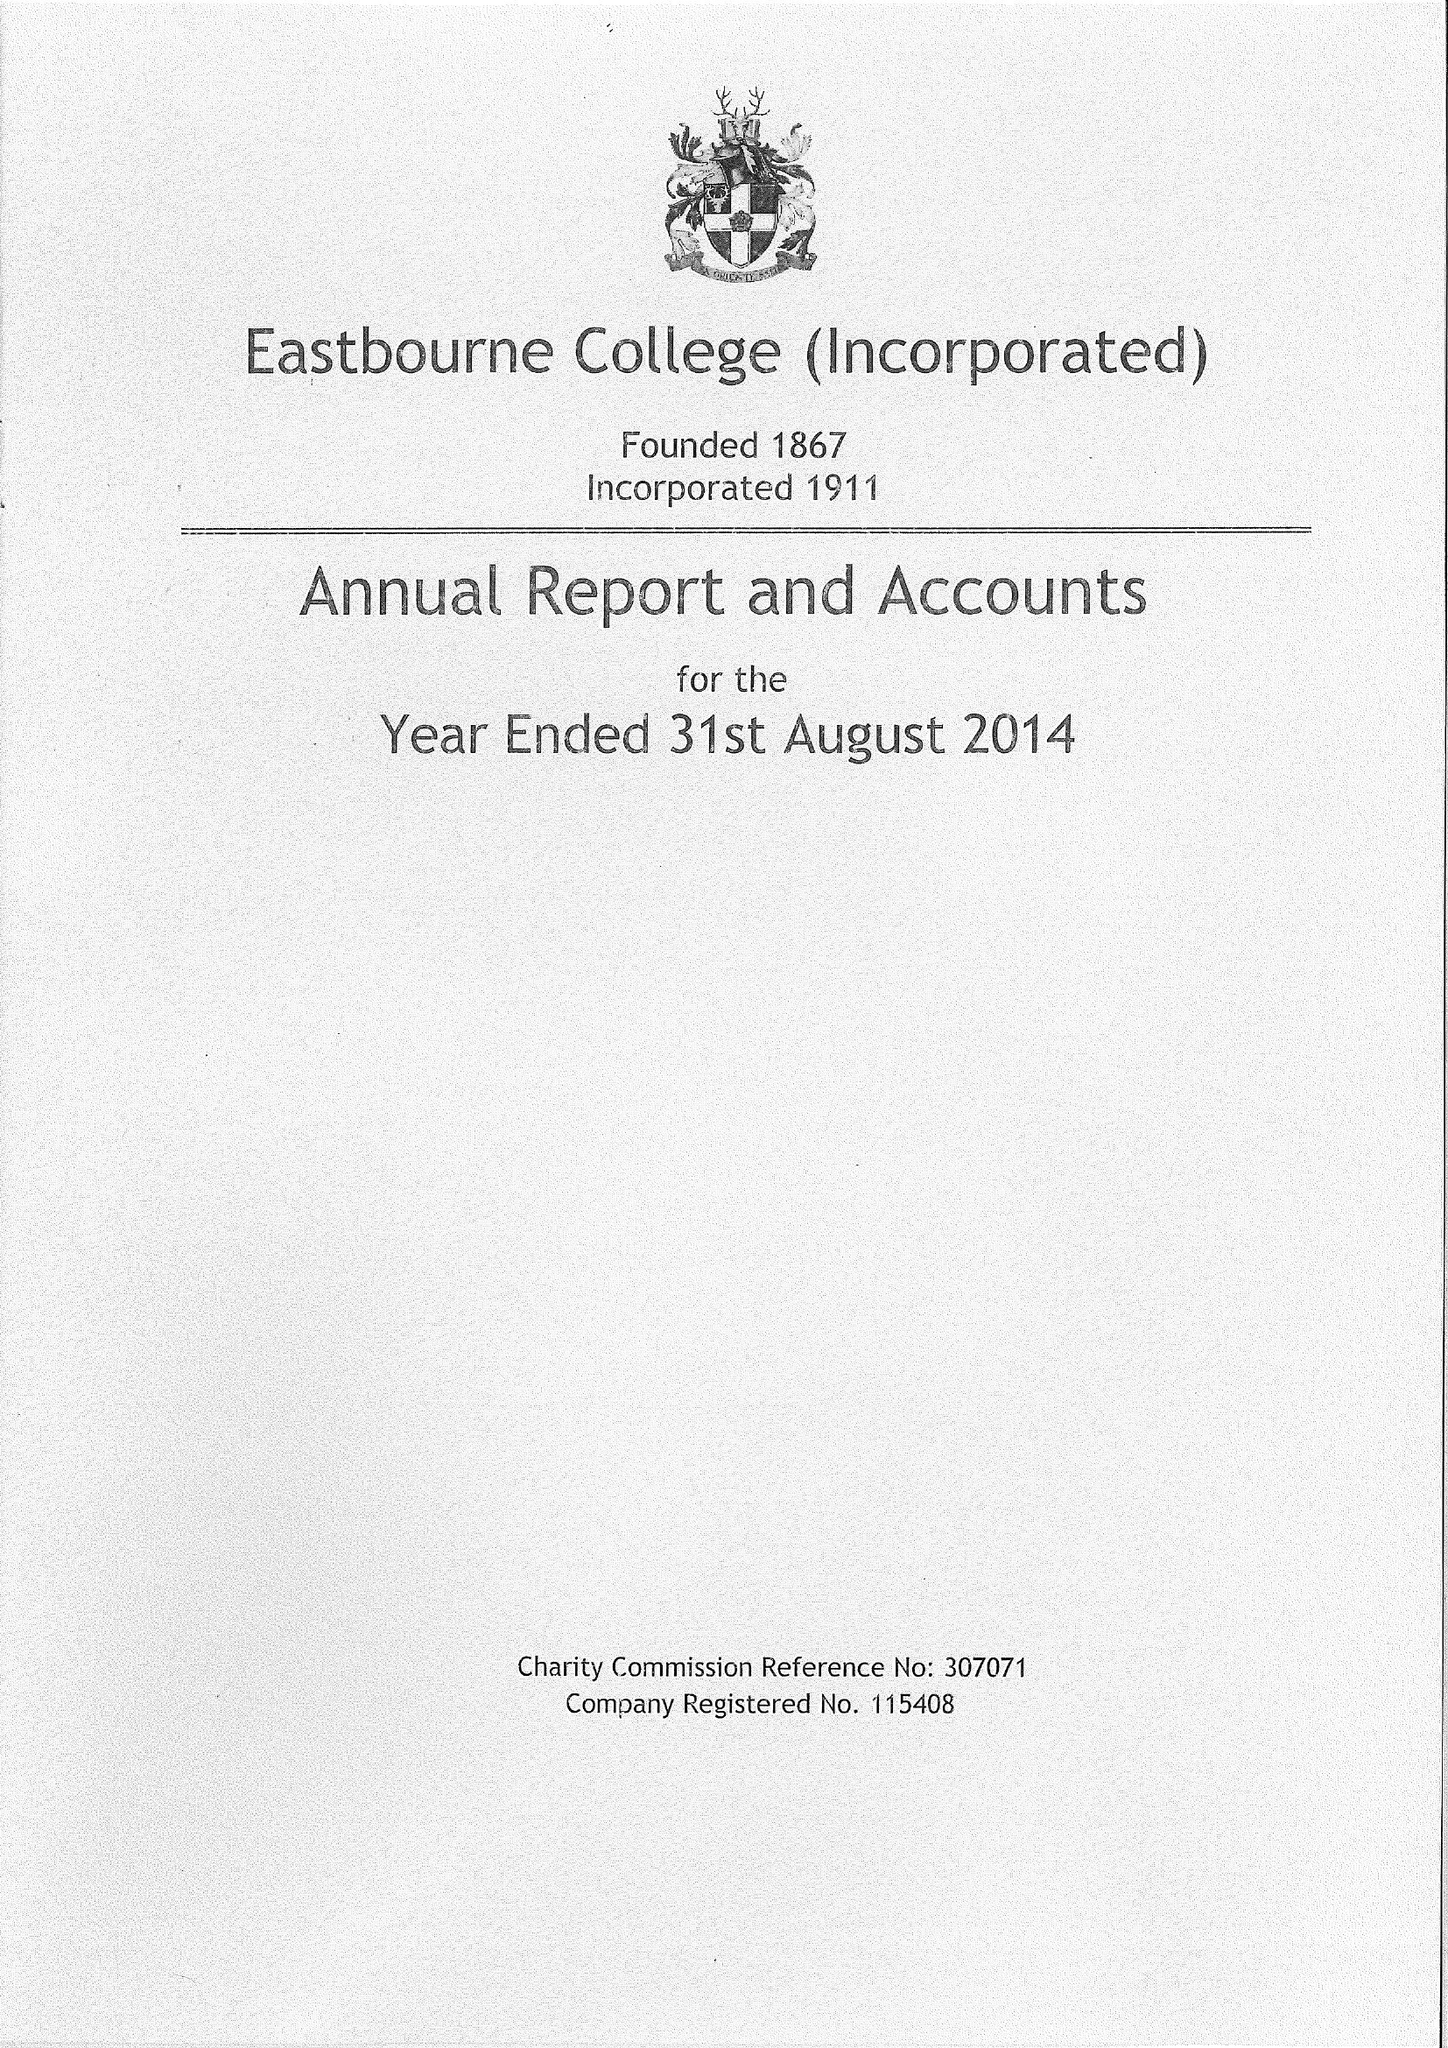What is the value for the income_annually_in_british_pounds?
Answer the question using a single word or phrase. 21336000.00 